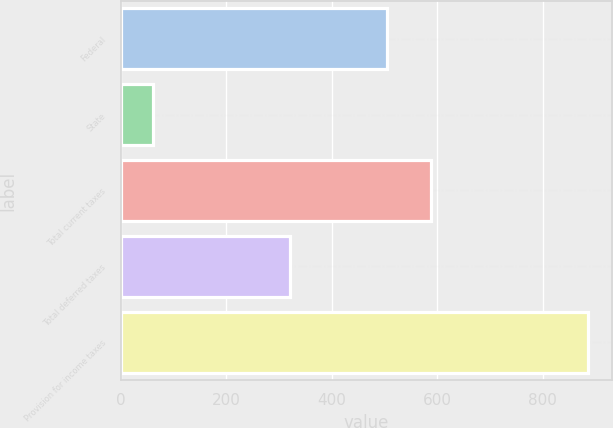<chart> <loc_0><loc_0><loc_500><loc_500><bar_chart><fcel>Federal<fcel>State<fcel>Total current taxes<fcel>Total deferred taxes<fcel>Provision for income taxes<nl><fcel>505<fcel>61<fcel>587.5<fcel>320<fcel>886<nl></chart> 